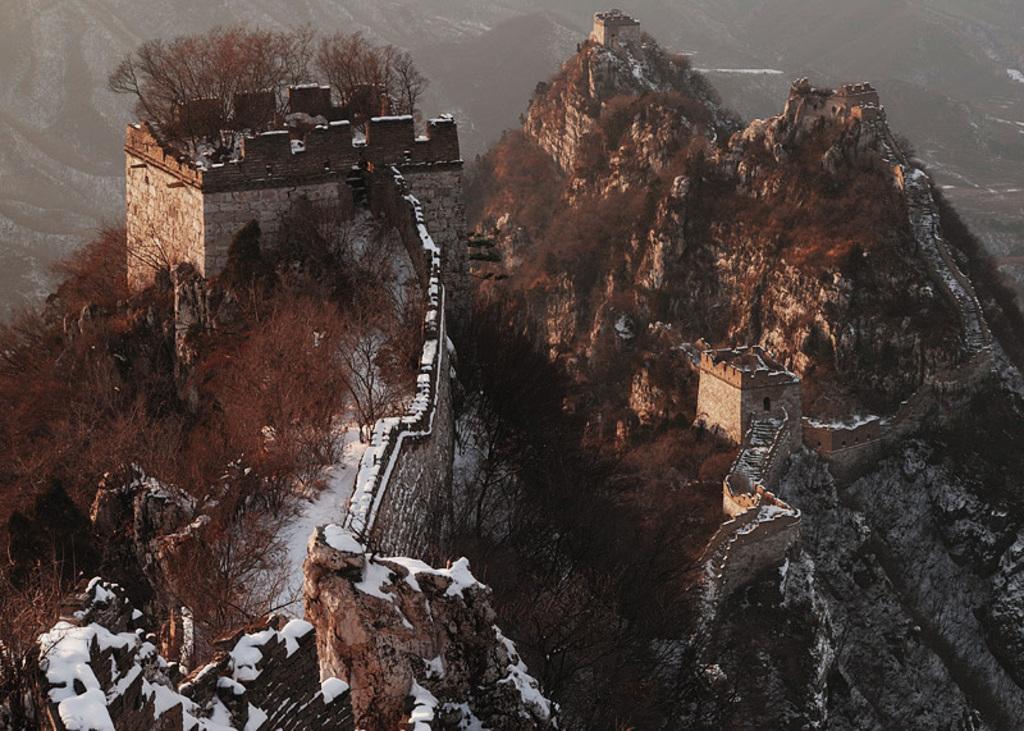How would you summarize this image in a sentence or two? In this image we can see group of buildings on mountains ,group of trees and some snow. 